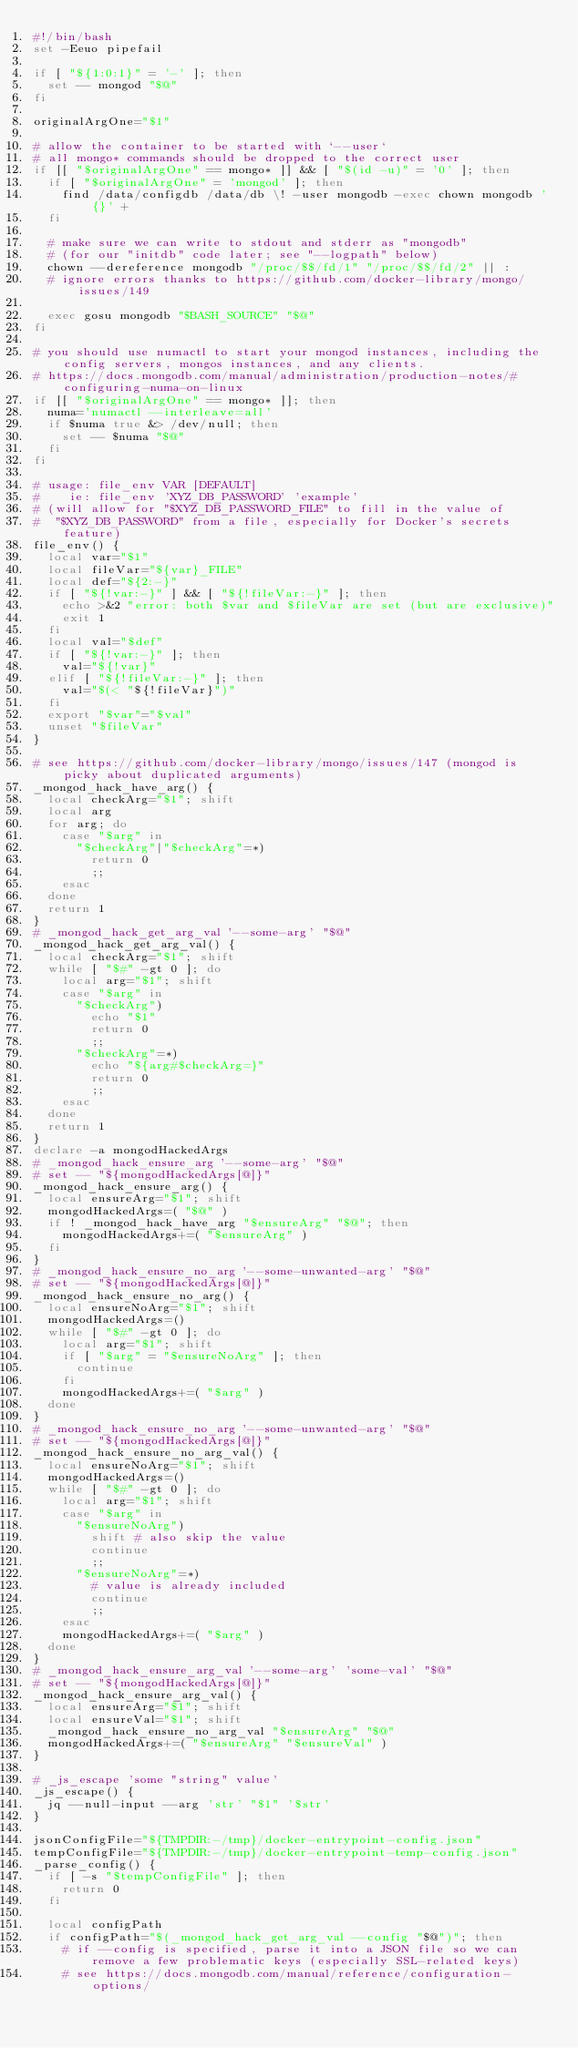Convert code to text. <code><loc_0><loc_0><loc_500><loc_500><_Bash_>#!/bin/bash
set -Eeuo pipefail

if [ "${1:0:1}" = '-' ]; then
	set -- mongod "$@"
fi

originalArgOne="$1"

# allow the container to be started with `--user`
# all mongo* commands should be dropped to the correct user
if [[ "$originalArgOne" == mongo* ]] && [ "$(id -u)" = '0' ]; then
	if [ "$originalArgOne" = 'mongod' ]; then
		find /data/configdb /data/db \! -user mongodb -exec chown mongodb '{}' +
	fi

	# make sure we can write to stdout and stderr as "mongodb"
	# (for our "initdb" code later; see "--logpath" below)
	chown --dereference mongodb "/proc/$$/fd/1" "/proc/$$/fd/2" || :
	# ignore errors thanks to https://github.com/docker-library/mongo/issues/149

	exec gosu mongodb "$BASH_SOURCE" "$@"
fi

# you should use numactl to start your mongod instances, including the config servers, mongos instances, and any clients.
# https://docs.mongodb.com/manual/administration/production-notes/#configuring-numa-on-linux
if [[ "$originalArgOne" == mongo* ]]; then
	numa='numactl --interleave=all'
	if $numa true &> /dev/null; then
		set -- $numa "$@"
	fi
fi

# usage: file_env VAR [DEFAULT]
#    ie: file_env 'XYZ_DB_PASSWORD' 'example'
# (will allow for "$XYZ_DB_PASSWORD_FILE" to fill in the value of
#  "$XYZ_DB_PASSWORD" from a file, especially for Docker's secrets feature)
file_env() {
	local var="$1"
	local fileVar="${var}_FILE"
	local def="${2:-}"
	if [ "${!var:-}" ] && [ "${!fileVar:-}" ]; then
		echo >&2 "error: both $var and $fileVar are set (but are exclusive)"
		exit 1
	fi
	local val="$def"
	if [ "${!var:-}" ]; then
		val="${!var}"
	elif [ "${!fileVar:-}" ]; then
		val="$(< "${!fileVar}")"
	fi
	export "$var"="$val"
	unset "$fileVar"
}

# see https://github.com/docker-library/mongo/issues/147 (mongod is picky about duplicated arguments)
_mongod_hack_have_arg() {
	local checkArg="$1"; shift
	local arg
	for arg; do
		case "$arg" in
			"$checkArg"|"$checkArg"=*)
				return 0
				;;
		esac
	done
	return 1
}
# _mongod_hack_get_arg_val '--some-arg' "$@"
_mongod_hack_get_arg_val() {
	local checkArg="$1"; shift
	while [ "$#" -gt 0 ]; do
		local arg="$1"; shift
		case "$arg" in
			"$checkArg")
				echo "$1"
				return 0
				;;
			"$checkArg"=*)
				echo "${arg#$checkArg=}"
				return 0
				;;
		esac
	done
	return 1
}
declare -a mongodHackedArgs
# _mongod_hack_ensure_arg '--some-arg' "$@"
# set -- "${mongodHackedArgs[@]}"
_mongod_hack_ensure_arg() {
	local ensureArg="$1"; shift
	mongodHackedArgs=( "$@" )
	if ! _mongod_hack_have_arg "$ensureArg" "$@"; then
		mongodHackedArgs+=( "$ensureArg" )
	fi
}
# _mongod_hack_ensure_no_arg '--some-unwanted-arg' "$@"
# set -- "${mongodHackedArgs[@]}"
_mongod_hack_ensure_no_arg() {
	local ensureNoArg="$1"; shift
	mongodHackedArgs=()
	while [ "$#" -gt 0 ]; do
		local arg="$1"; shift
		if [ "$arg" = "$ensureNoArg" ]; then
			continue
		fi
		mongodHackedArgs+=( "$arg" )
	done
}
# _mongod_hack_ensure_no_arg '--some-unwanted-arg' "$@"
# set -- "${mongodHackedArgs[@]}"
_mongod_hack_ensure_no_arg_val() {
	local ensureNoArg="$1"; shift
	mongodHackedArgs=()
	while [ "$#" -gt 0 ]; do
		local arg="$1"; shift
		case "$arg" in
			"$ensureNoArg")
				shift # also skip the value
				continue
				;;
			"$ensureNoArg"=*)
				# value is already included
				continue
				;;
		esac
		mongodHackedArgs+=( "$arg" )
	done
}
# _mongod_hack_ensure_arg_val '--some-arg' 'some-val' "$@"
# set -- "${mongodHackedArgs[@]}"
_mongod_hack_ensure_arg_val() {
	local ensureArg="$1"; shift
	local ensureVal="$1"; shift
	_mongod_hack_ensure_no_arg_val "$ensureArg" "$@"
	mongodHackedArgs+=( "$ensureArg" "$ensureVal" )
}

# _js_escape 'some "string" value'
_js_escape() {
	jq --null-input --arg 'str' "$1" '$str'
}

jsonConfigFile="${TMPDIR:-/tmp}/docker-entrypoint-config.json"
tempConfigFile="${TMPDIR:-/tmp}/docker-entrypoint-temp-config.json"
_parse_config() {
	if [ -s "$tempConfigFile" ]; then
		return 0
	fi

	local configPath
	if configPath="$(_mongod_hack_get_arg_val --config "$@")"; then
		# if --config is specified, parse it into a JSON file so we can remove a few problematic keys (especially SSL-related keys)
		# see https://docs.mongodb.com/manual/reference/configuration-options/</code> 